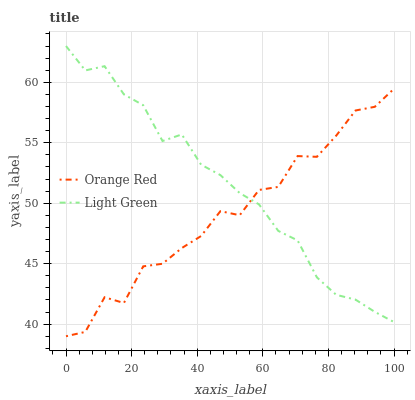Does Orange Red have the minimum area under the curve?
Answer yes or no. Yes. Does Light Green have the maximum area under the curve?
Answer yes or no. Yes. Does Light Green have the minimum area under the curve?
Answer yes or no. No. Is Light Green the smoothest?
Answer yes or no. Yes. Is Orange Red the roughest?
Answer yes or no. Yes. Is Light Green the roughest?
Answer yes or no. No. Does Light Green have the lowest value?
Answer yes or no. No. Does Light Green have the highest value?
Answer yes or no. Yes. Does Orange Red intersect Light Green?
Answer yes or no. Yes. Is Orange Red less than Light Green?
Answer yes or no. No. Is Orange Red greater than Light Green?
Answer yes or no. No. 